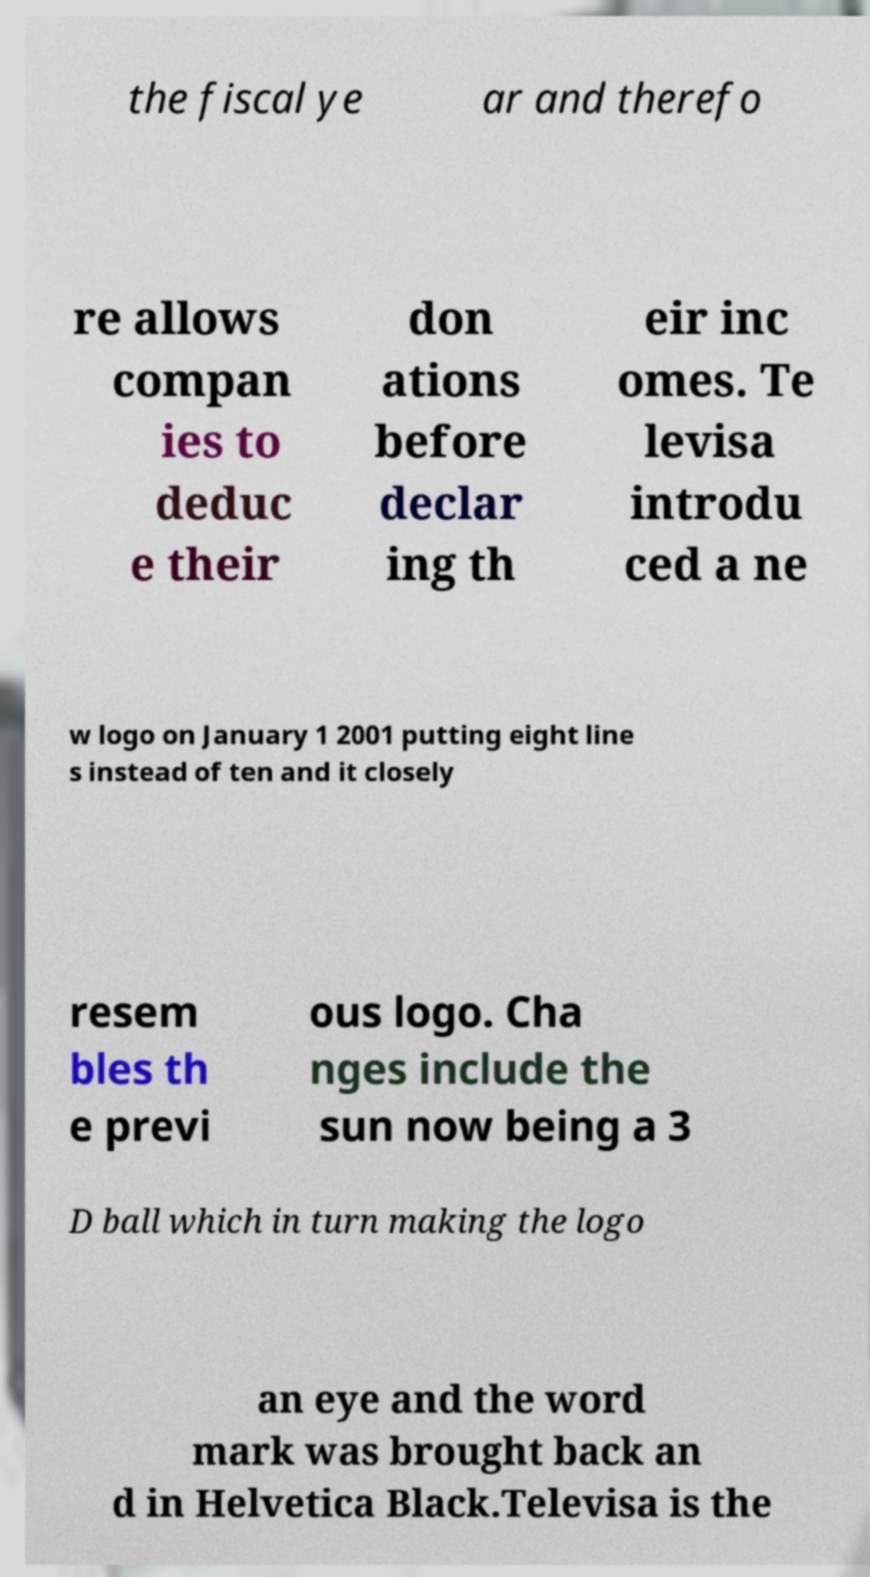There's text embedded in this image that I need extracted. Can you transcribe it verbatim? the fiscal ye ar and therefo re allows compan ies to deduc e their don ations before declar ing th eir inc omes. Te levisa introdu ced a ne w logo on January 1 2001 putting eight line s instead of ten and it closely resem bles th e previ ous logo. Cha nges include the sun now being a 3 D ball which in turn making the logo an eye and the word mark was brought back an d in Helvetica Black.Televisa is the 